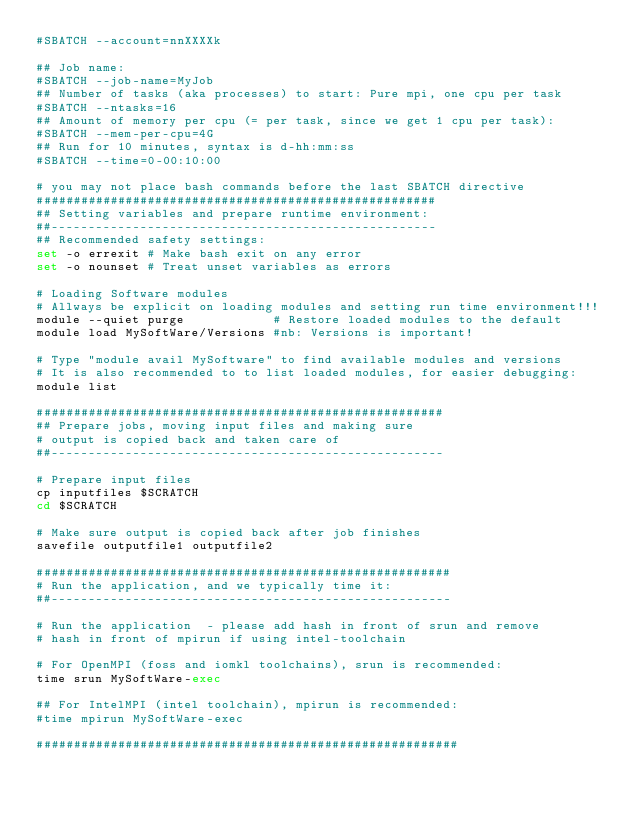Convert code to text. <code><loc_0><loc_0><loc_500><loc_500><_Bash_>#SBATCH --account=nnXXXXk 

## Job name:
#SBATCH --job-name=MyJob
## Number of tasks (aka processes) to start: Pure mpi, one cpu per task
#SBATCH --ntasks=16
## Amount of memory per cpu (= per task, since we get 1 cpu per task):
#SBATCH --mem-per-cpu=4G
## Run for 10 minutes, syntax is d-hh:mm:ss
#SBATCH --time=0-00:10:00 

# you may not place bash commands before the last SBATCH directive
######################################################
## Setting variables and prepare runtime environment:
##----------------------------------------------------
## Recommended safety settings:
set -o errexit # Make bash exit on any error
set -o nounset # Treat unset variables as errors

# Loading Software modules
# Allways be explicit on loading modules and setting run time environment!!!
module --quiet purge            # Restore loaded modules to the default
module load MySoftWare/Versions #nb: Versions is important!

# Type "module avail MySoftware" to find available modules and versions
# It is also recommended to to list loaded modules, for easier debugging:
module list  

#######################################################
## Prepare jobs, moving input files and making sure 
# output is copied back and taken care of
##-----------------------------------------------------

# Prepare input files
cp inputfiles $SCRATCH
cd $SCRATCH

# Make sure output is copied back after job finishes
savefile outputfile1 outputfile2

########################################################
# Run the application, and we typically time it:
##------------------------------------------------------
 
# Run the application  - please add hash in front of srun and remove 
# hash in front of mpirun if using intel-toolchain 

# For OpenMPI (foss and iomkl toolchains), srun is recommended:
time srun MySoftWare-exec

## For IntelMPI (intel toolchain), mpirun is recommended:
#time mpirun MySoftWare-exec

#########################################################</code> 